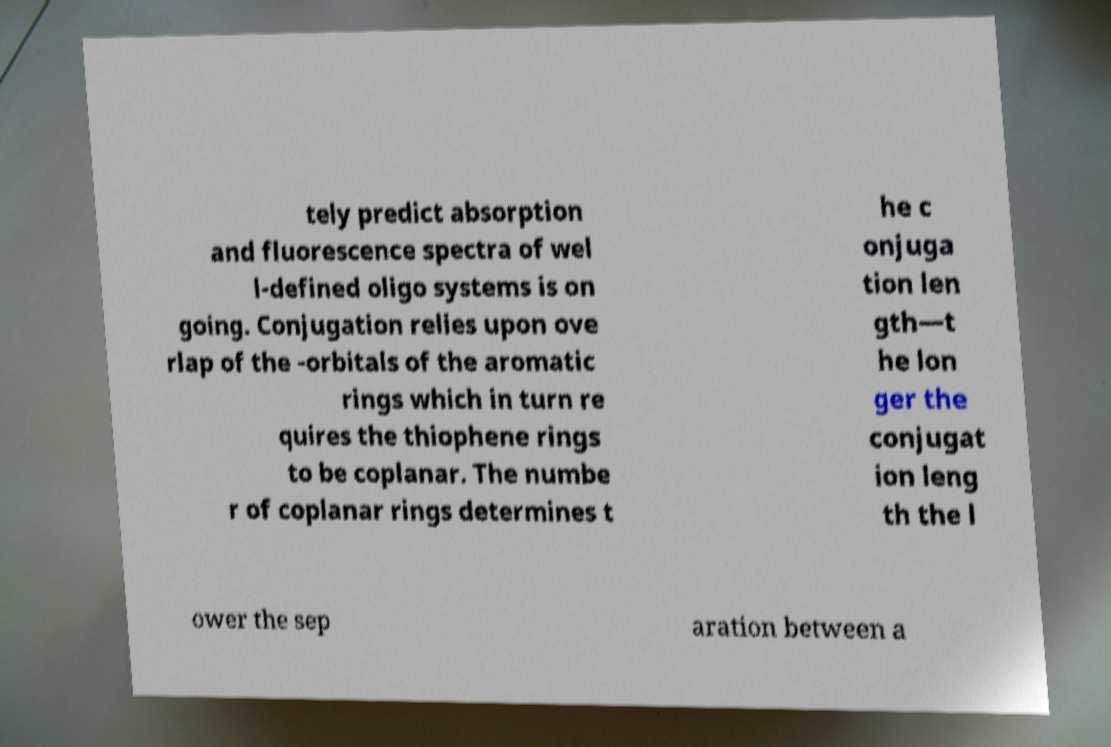There's text embedded in this image that I need extracted. Can you transcribe it verbatim? tely predict absorption and fluorescence spectra of wel l-defined oligo systems is on going. Conjugation relies upon ove rlap of the -orbitals of the aromatic rings which in turn re quires the thiophene rings to be coplanar. The numbe r of coplanar rings determines t he c onjuga tion len gth—t he lon ger the conjugat ion leng th the l ower the sep aration between a 